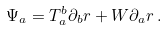Convert formula to latex. <formula><loc_0><loc_0><loc_500><loc_500>\Psi _ { a } = T ^ { b } _ { a } \partial _ { b } r + W \partial _ { a } r \, .</formula> 